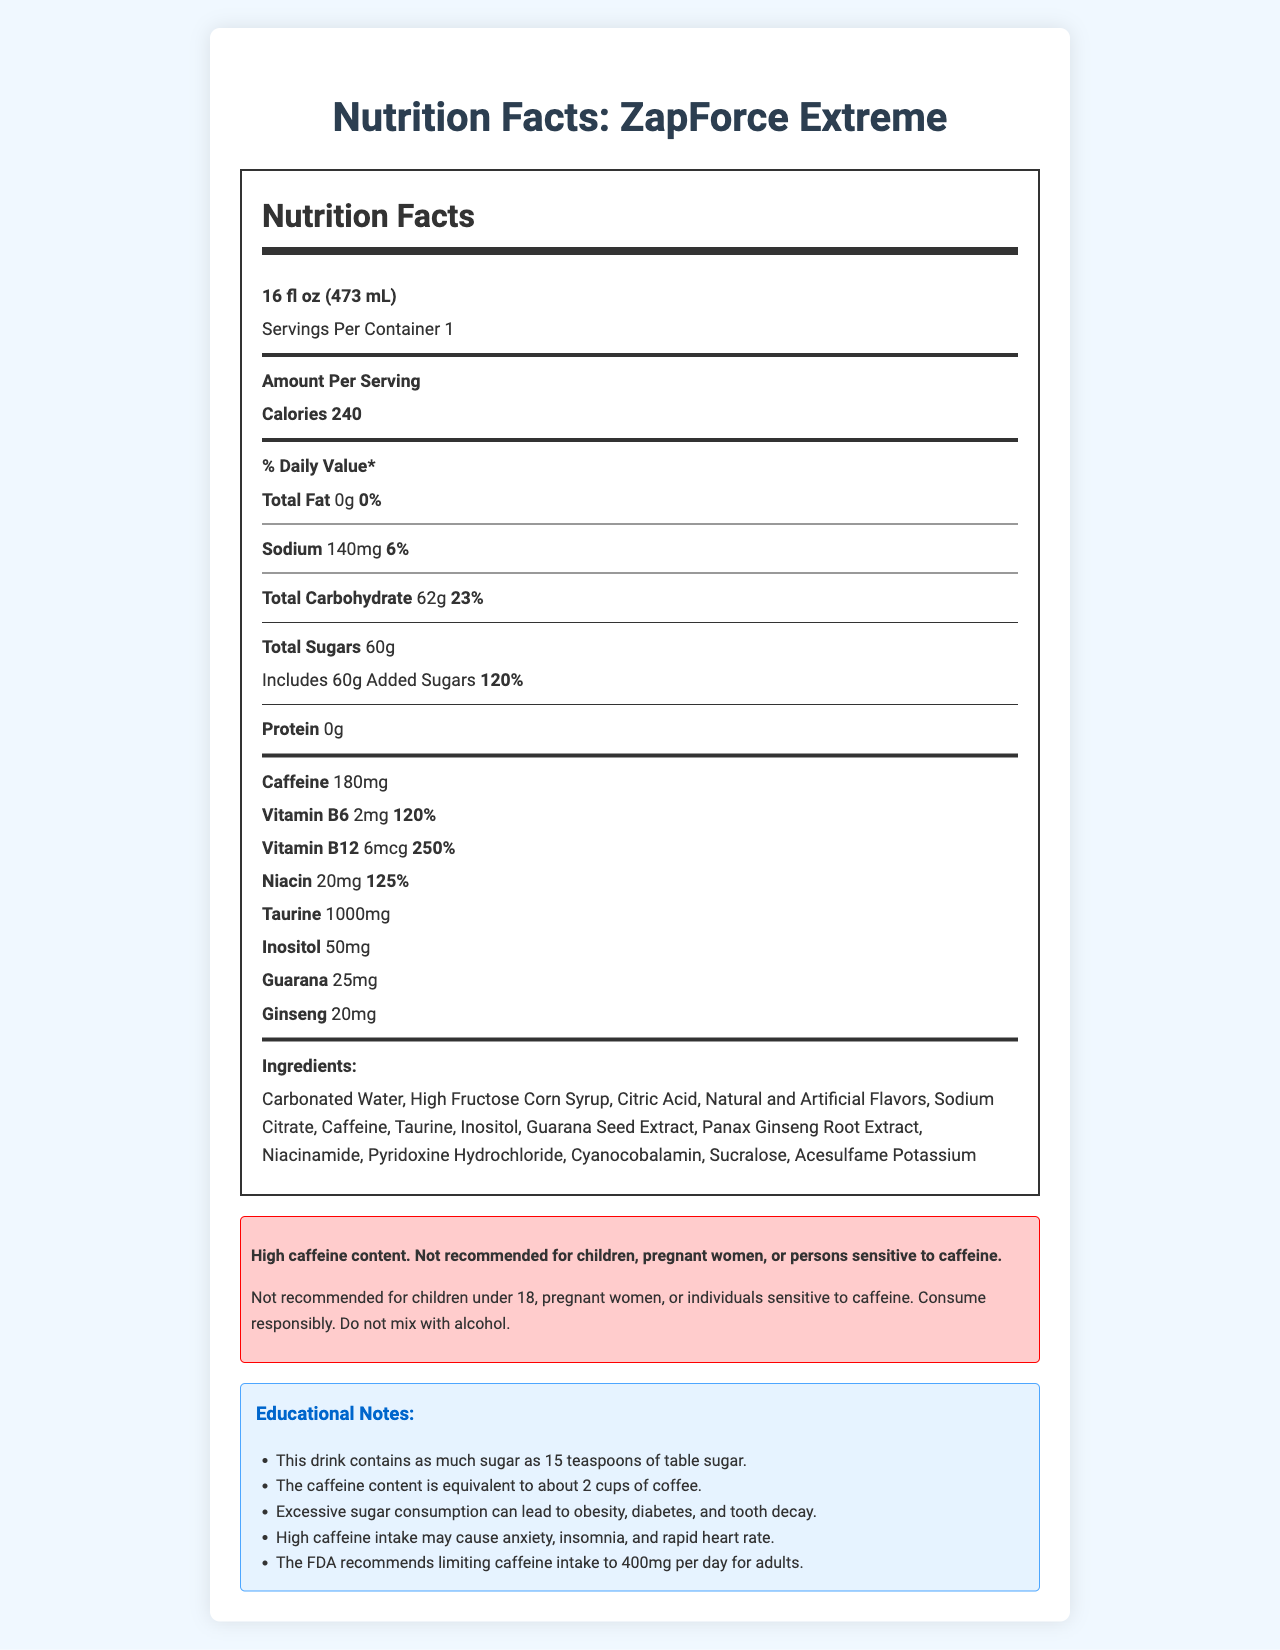who should avoid consuming ZapForce Extreme? The warning statement specifically mentions that the product is not recommended for children under 18, pregnant women, or individuals sensitive to caffeine.
Answer: children under 18, pregnant women, or individuals sensitive to caffeine what is the serving size of ZapForce Extreme? According to the nutrition facts label, the serving size is clearly indicated as 16 fl oz (473 mL).
Answer: 16 fl oz (473 mL) how many grams of total sugars are in one serving? The label lists the total sugars as 60g per serving.
Answer: 60g what is the caffeine content in ZapForce Extreme? The nutrition facts label specifies that each serving contains 180mg of caffeine.
Answer: 180mg how many calories are there per serving? The label clearly states that each serving has 240 calories.
Answer: 240 calories what percentage of the daily value for Vitamin B12 does one serving contain? The label indicates that one serving provides 250% of the daily value for Vitamin B12.
Answer: 250% which ingredient is listed first in the ingredients list? The first ingredient listed is Carbonated Water.
Answer: Carbonated Water how does the caffeine content compare to cups of coffee? A. Equivalent to about 1 cup B. Equivalent to about 2 cups C. Equivalent to about 3 cups D. Equivalent to about 4 cups The educational notes section mentions that the caffeine content is equivalent to about 2 cups of coffee.
Answer: B. Equivalent to about 2 cups what is the daily value percentage for total carbohydrates? A. 20% B. 22% C. 23% D. 24% The nutrition facts indicate that the total carbohydrate content is 23% of the daily value.
Answer: C. 23% True or False: The product includes added sugars. The label explicitly states that 60g of the total sugars are added sugars.
Answer: True summarize the main information provided in the nutrition facts label. The label provides a comprehensive breakdown of the drink's nutritional content, highlights the potentially harmful levels of sugar and caffeine, and includes educational notes warning about the health implications of consuming these substances.
Answer: The Nutrition Facts label details the serving size, calorie content, total fat, sodium, carbohydrates, sugars, protein, caffeine, vitamins, and other ingredients of ZapForce Extreme. It highlights high sugar (120% daily value) and caffeine content (180mg), and includes a warning about caffeine intake. Educational notes caution about the health risks of excessive sugar and caffeine consumption. what is the source of caffeine in ZapForce Extreme? Although the label lists ingredients including caffeine, guarana seed extract, and ginseng root extract, it does not specify which ingredient is the primary source of caffeine.
Answer: Cannot be determined 